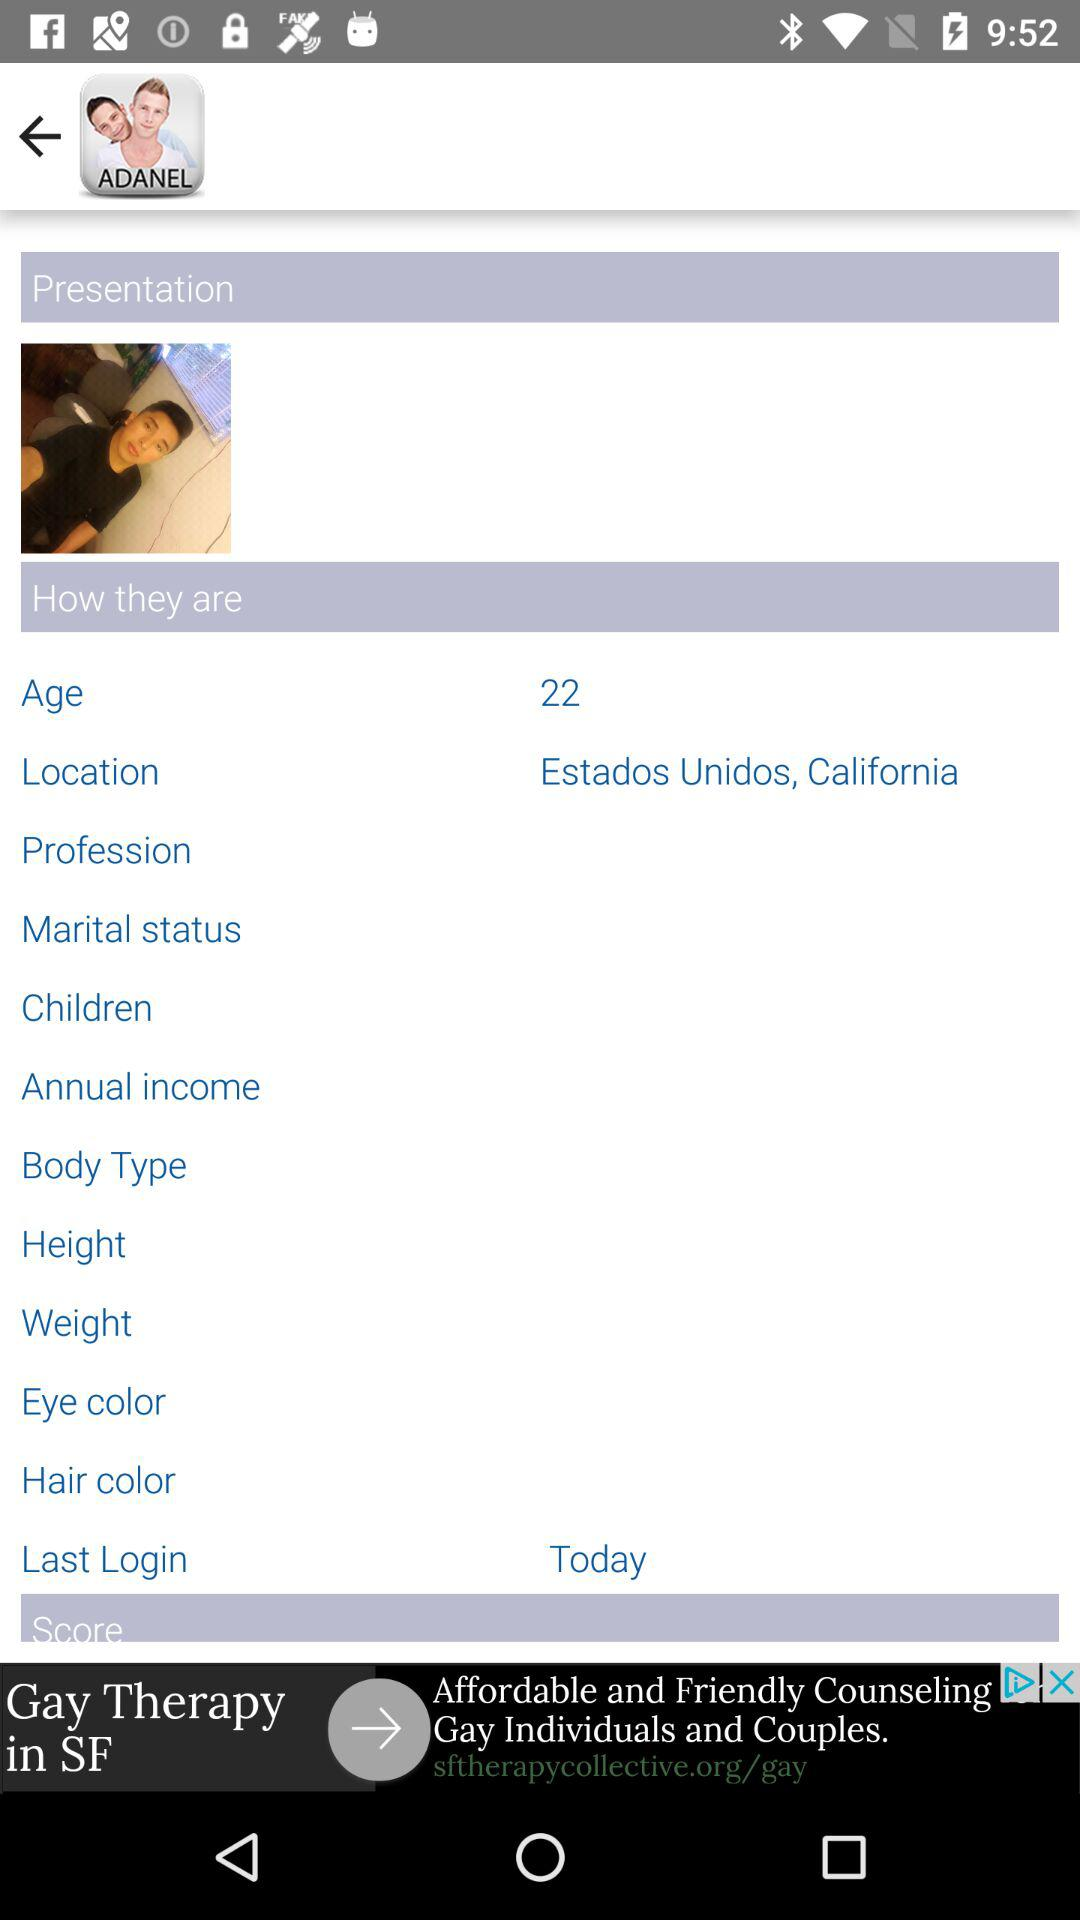What is the status of the "Last Login"? The status of the "Last Login" is "Today". 